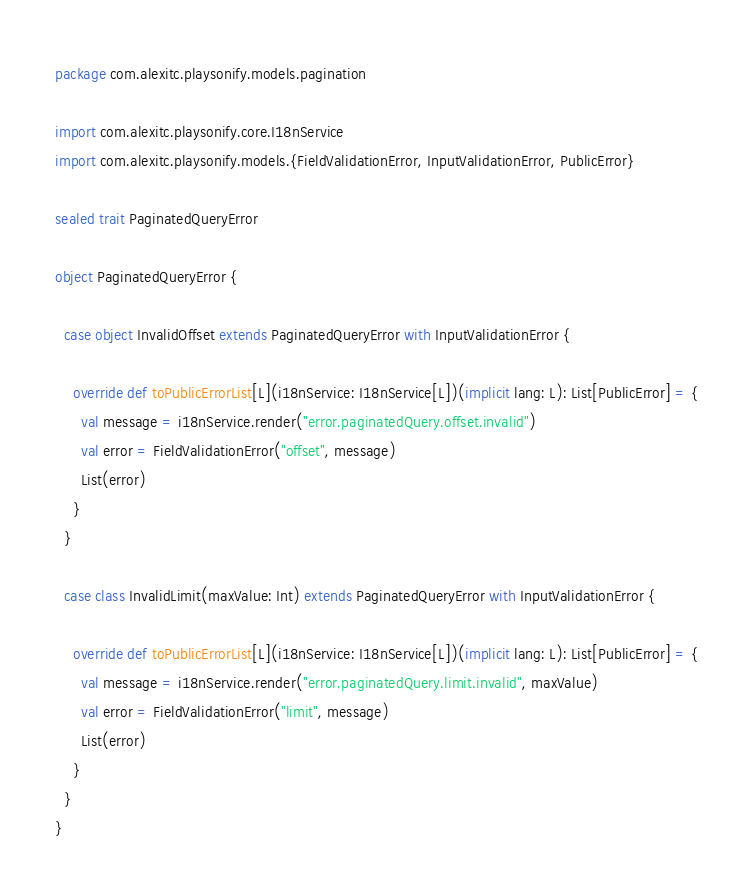Convert code to text. <code><loc_0><loc_0><loc_500><loc_500><_Scala_>package com.alexitc.playsonify.models.pagination

import com.alexitc.playsonify.core.I18nService
import com.alexitc.playsonify.models.{FieldValidationError, InputValidationError, PublicError}

sealed trait PaginatedQueryError

object PaginatedQueryError {

  case object InvalidOffset extends PaginatedQueryError with InputValidationError {

    override def toPublicErrorList[L](i18nService: I18nService[L])(implicit lang: L): List[PublicError] = {
      val message = i18nService.render("error.paginatedQuery.offset.invalid")
      val error = FieldValidationError("offset", message)
      List(error)
    }
  }

  case class InvalidLimit(maxValue: Int) extends PaginatedQueryError with InputValidationError {

    override def toPublicErrorList[L](i18nService: I18nService[L])(implicit lang: L): List[PublicError] = {
      val message = i18nService.render("error.paginatedQuery.limit.invalid", maxValue)
      val error = FieldValidationError("limit", message)
      List(error)
    }
  }
}
</code> 